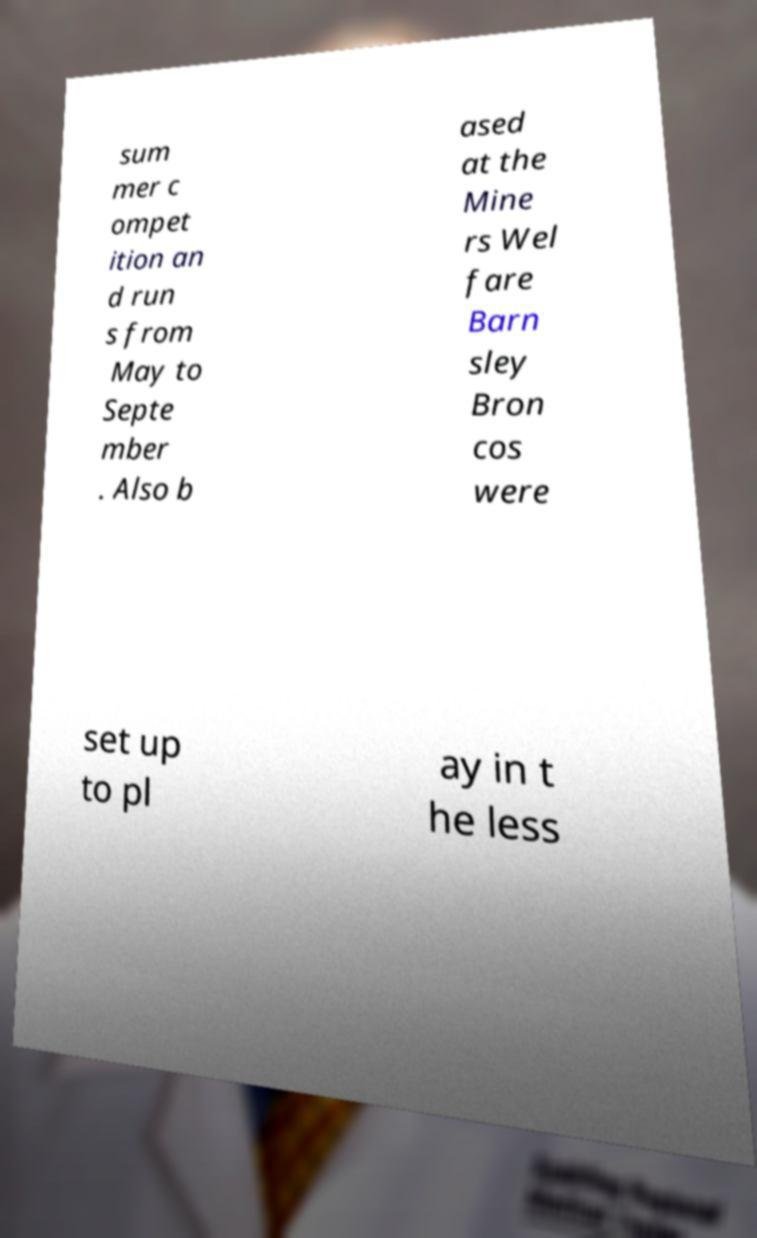Please identify and transcribe the text found in this image. sum mer c ompet ition an d run s from May to Septe mber . Also b ased at the Mine rs Wel fare Barn sley Bron cos were set up to pl ay in t he less 